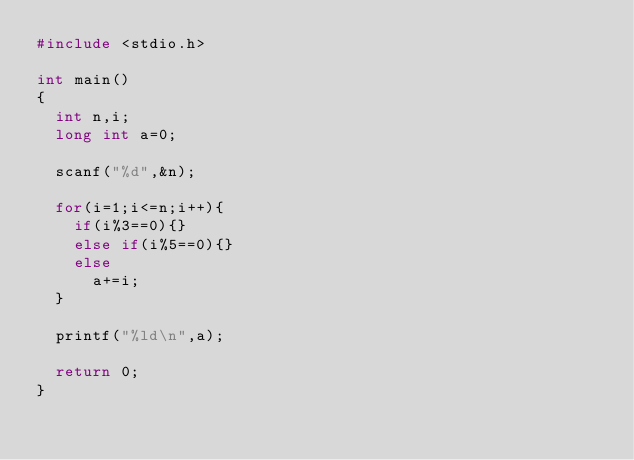Convert code to text. <code><loc_0><loc_0><loc_500><loc_500><_C_>#include <stdio.h>
 
int main()
{
  int n,i;
  long int a=0;
  
  scanf("%d",&n);
  
  for(i=1;i<=n;i++){
    if(i%3==0){}
    else if(i%5==0){}
    else 
      a+=i;
  }
  
  printf("%ld\n",a);
  
  return 0;
}</code> 